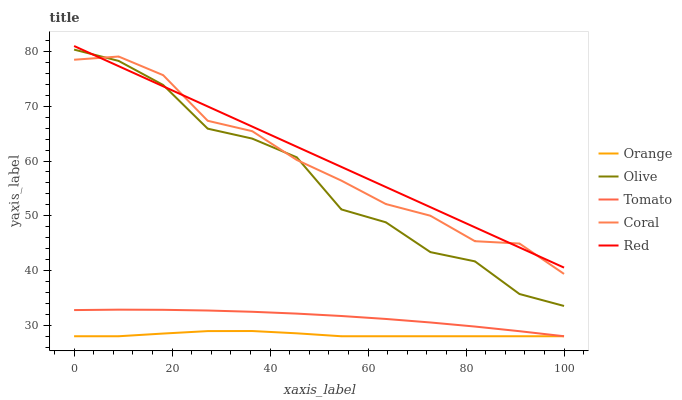Does Olive have the minimum area under the curve?
Answer yes or no. No. Does Olive have the maximum area under the curve?
Answer yes or no. No. Is Tomato the smoothest?
Answer yes or no. No. Is Tomato the roughest?
Answer yes or no. No. Does Olive have the lowest value?
Answer yes or no. No. Does Olive have the highest value?
Answer yes or no. No. Is Orange less than Olive?
Answer yes or no. Yes. Is Olive greater than Tomato?
Answer yes or no. Yes. Does Orange intersect Olive?
Answer yes or no. No. 